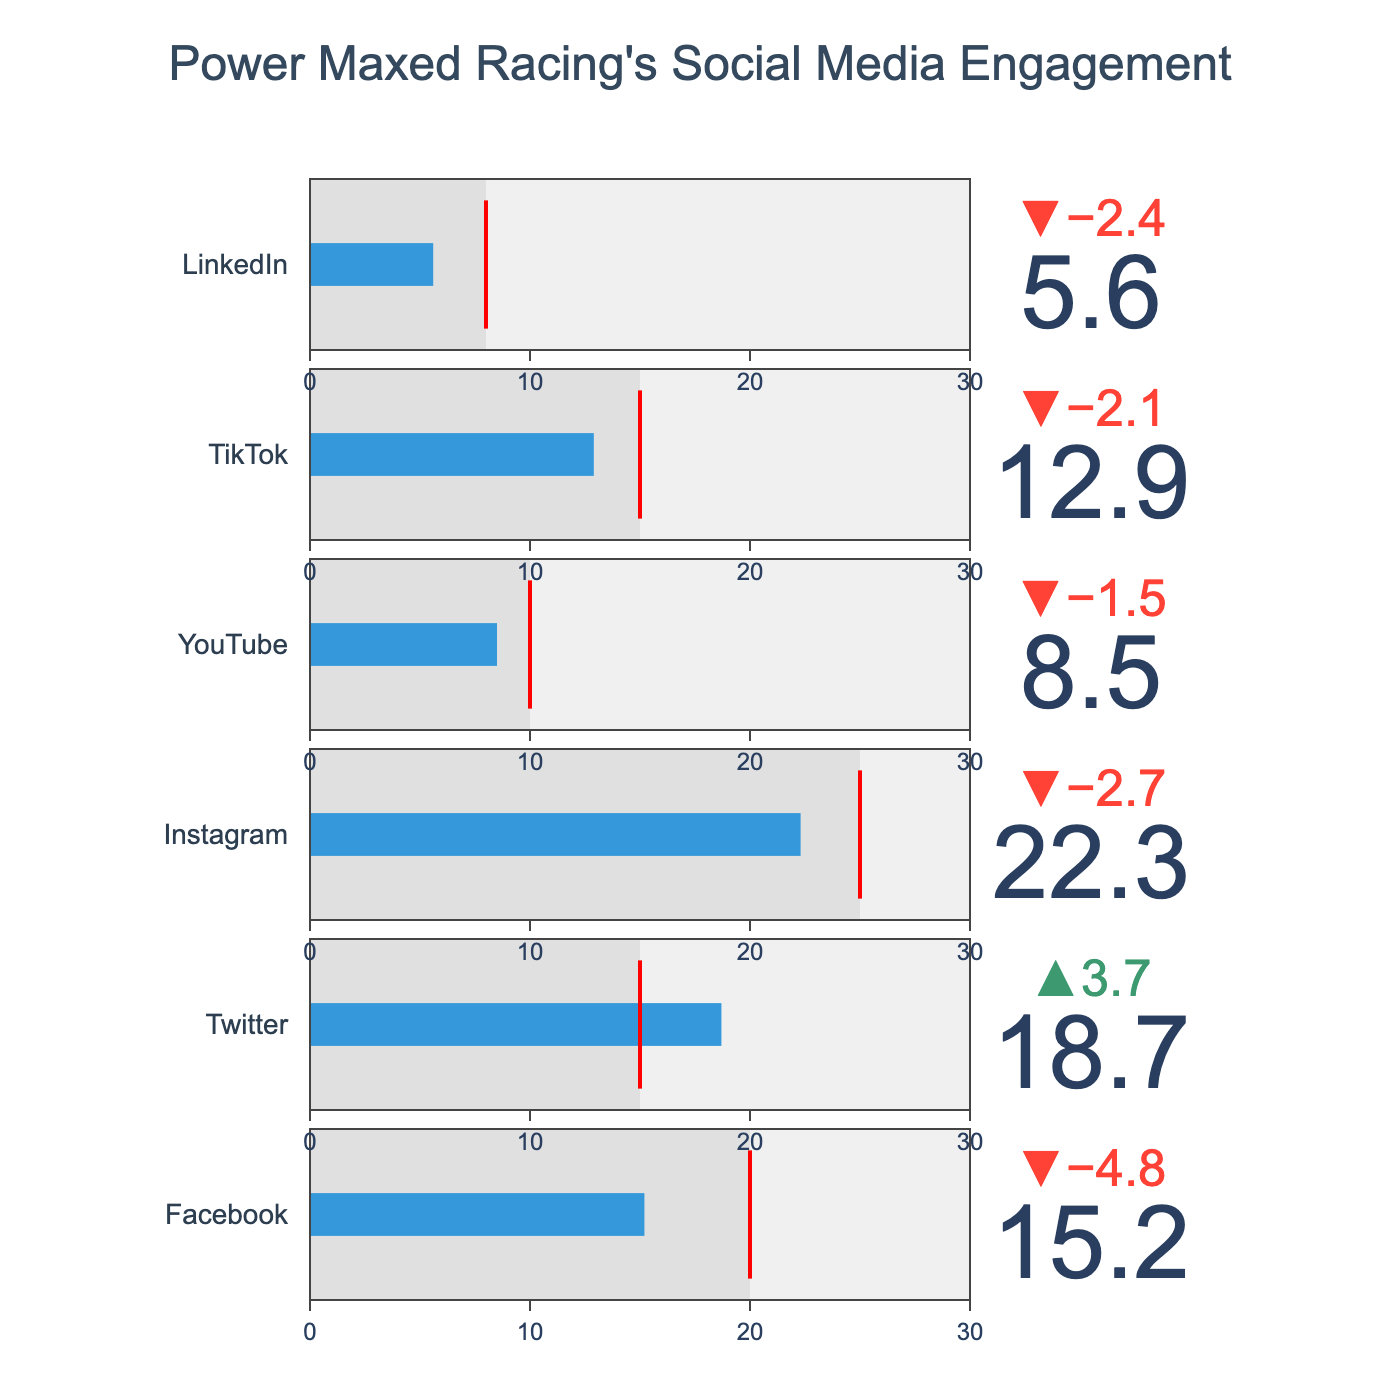what is the title of the chart? The title of the chart is located at the top center of the figure. The text describes the chart content.
Answer: Power Maxed Racing's Social Media Engagement what is the target engagement rate for YouTube? The target engagement rate for YouTube is shown in the chart within the YouTube row, marked by a red threshold line.
Answer: 10 which platform has the highest actual engagement rate? To determine the platform with the highest actual engagement rate, compare the values of 'Actual' for all platforms.
Answer: Instagram how much lower is the actual engagement rate on LinkedIn compared to its target? The actual engagement rate for LinkedIn is 5.6 and the target is 8. Subtract the actual from the target to find the difference.
Answer: 2.4 which platform has exceeded its target engagement rate? To find the platforms that have exceeded their targets, compare the actual engagement rate to the target rate for each platform.
Answer: Twitter how many platforms have an actual engagement rate below 10? Count the platforms with an actual engagement rate less than 10 by checking the corresponding values in the 'Actual' column.
Answer: 2 what is the average actual engagement rate across all platforms? Sum the actual engagement rates for all platforms and divide by the total number of platforms. (15.2 + 18.7 + 22.3 + 8.5 + 12.9 + 5.6) / 6 = 83.2 / 6
Answer: 13.87 which platform shows the smallest difference between actual and target engagement rates? Calculate the absolute differences between actual and target engagement rates for each platform, then find the smallest difference.
Answer: YouTube what is the overall target engagement rate across all platforms? Sum the target rates for all platforms to get the overall target. 20 + 15 + 25 + 10 + 15 + 8 = 93
Answer: 93 how does Facebook's actual engagement rate compare to Instagram's? Compare Facebook's actual rate (15.2) to Instagram's (22.3) to see which is higher.
Answer: lower 